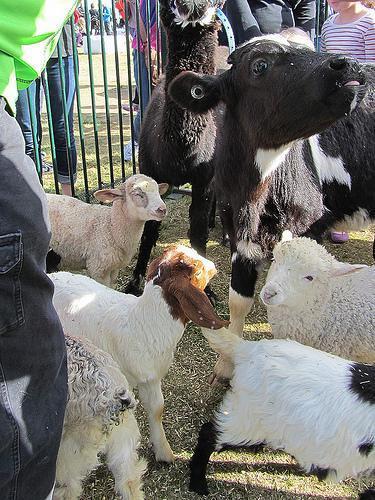How many black animals?
Give a very brief answer. 2. How many sheep faces can be seen?
Give a very brief answer. 2. 